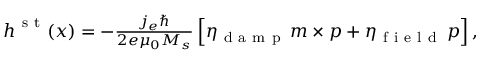Convert formula to latex. <formula><loc_0><loc_0><loc_500><loc_500>\begin{array} { r } { h ^ { s t } ( x ) = - \frac { j _ { e } } { 2 e \mu _ { 0 } M _ { s } } \left [ \eta _ { d a m p } \, m \times p + \eta _ { f i e l d } \, p \right ] , } \end{array}</formula> 